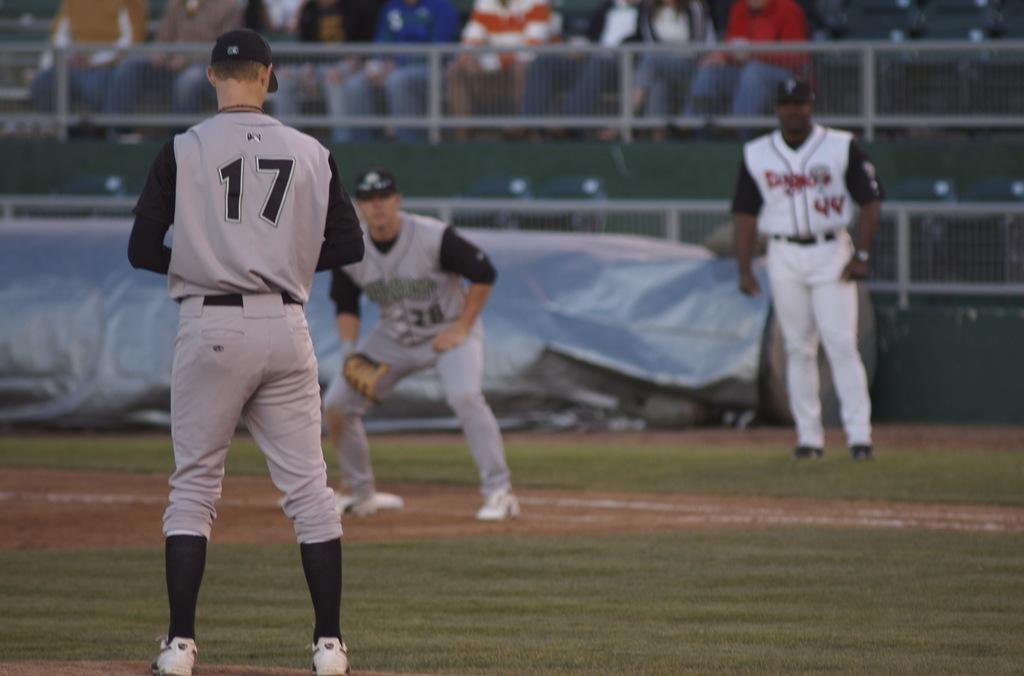Provide a one-sentence caption for the provided image. A baseball player with the number 17 on his shirt is about to pitch. 